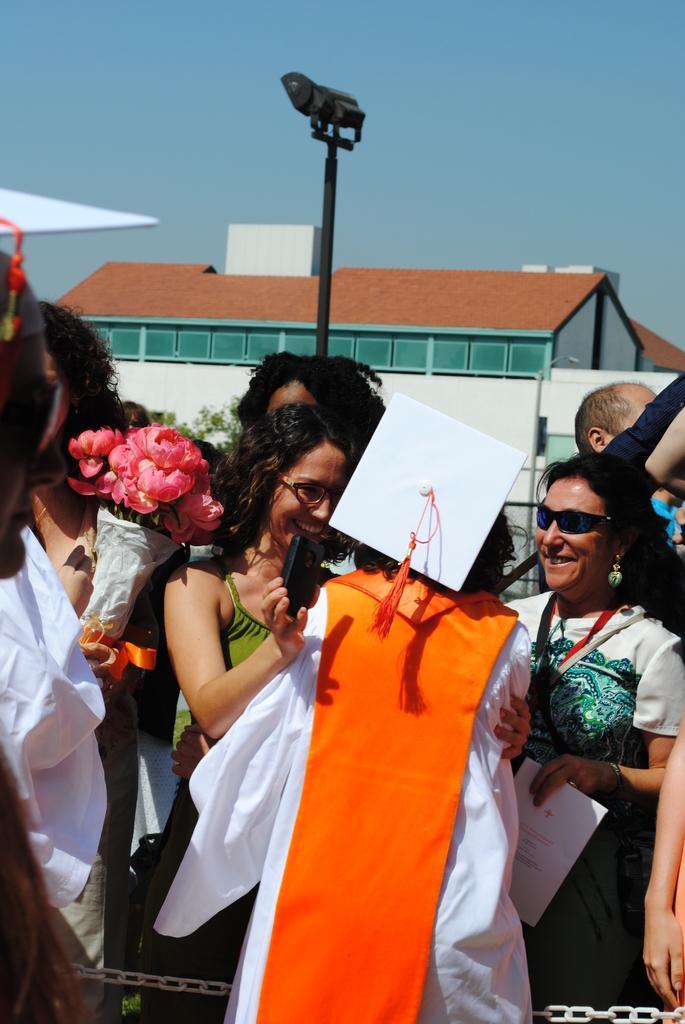Could you give a brief overview of what you see in this image? In this image at the bottom there are group of people who are standing and some of them are holding flower bouquets, and in the background there are some houses. In the center there is one pole and on the top of the image there is sky. 